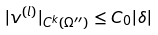<formula> <loc_0><loc_0><loc_500><loc_500>| v ^ { ( l ) } | _ { C ^ { k } ( \Omega ^ { \prime \prime } ) } \leq C _ { 0 } | \delta |</formula> 